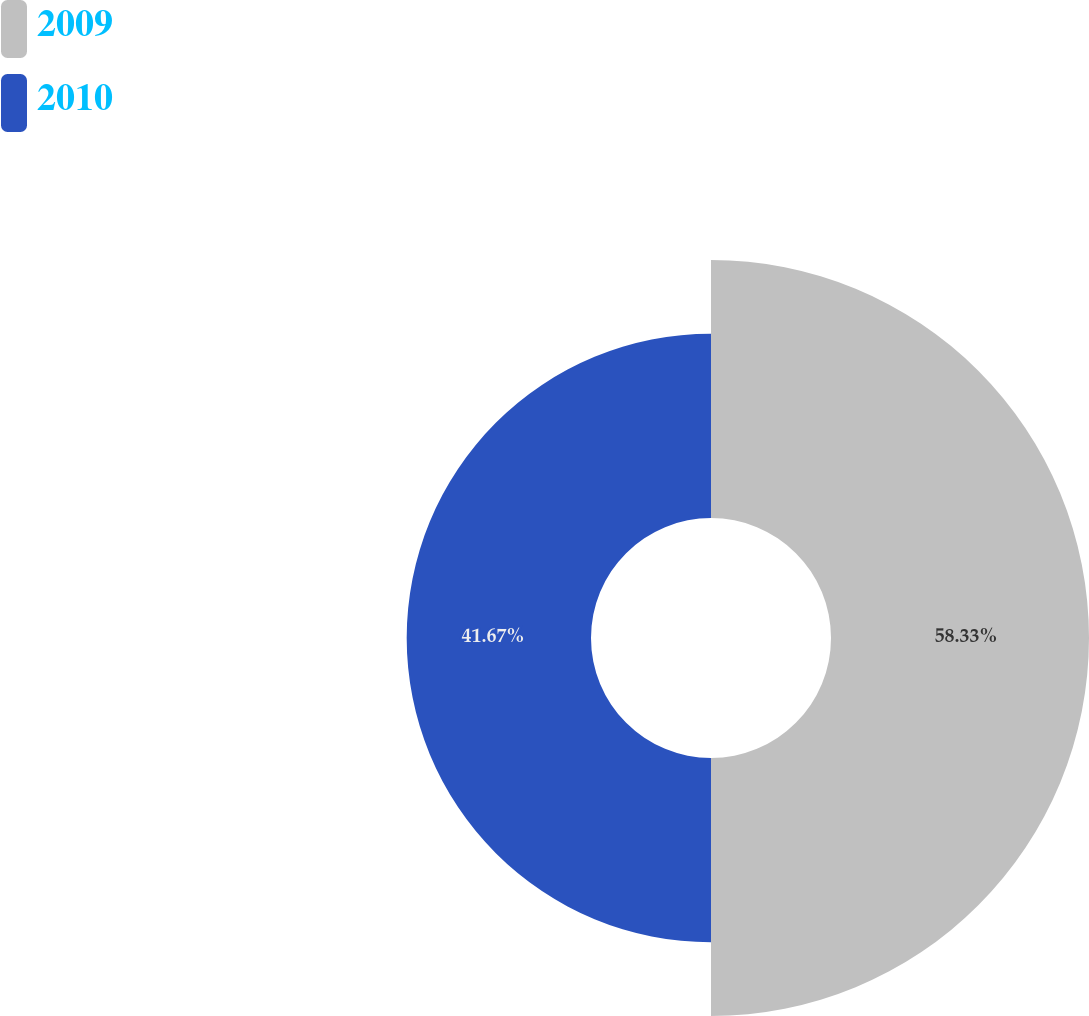<chart> <loc_0><loc_0><loc_500><loc_500><pie_chart><fcel>2009<fcel>2010<nl><fcel>58.33%<fcel>41.67%<nl></chart> 